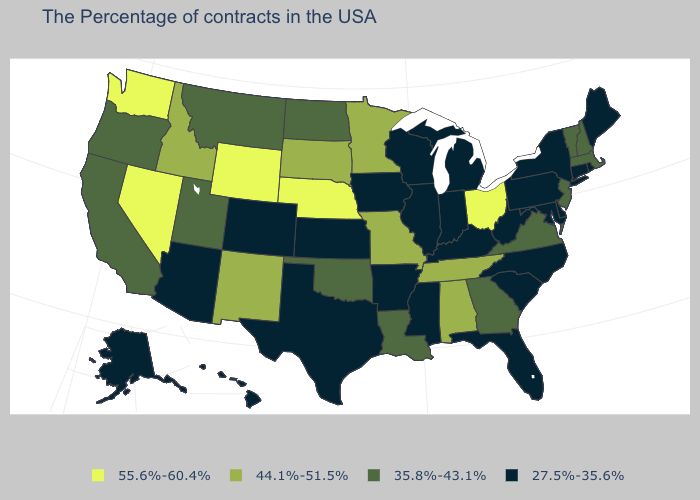Name the states that have a value in the range 35.8%-43.1%?
Short answer required. Massachusetts, New Hampshire, Vermont, New Jersey, Virginia, Georgia, Louisiana, Oklahoma, North Dakota, Utah, Montana, California, Oregon. Which states have the highest value in the USA?
Keep it brief. Ohio, Nebraska, Wyoming, Nevada, Washington. Does Alaska have the lowest value in the West?
Short answer required. Yes. What is the value of Louisiana?
Answer briefly. 35.8%-43.1%. What is the value of Minnesota?
Keep it brief. 44.1%-51.5%. Name the states that have a value in the range 55.6%-60.4%?
Short answer required. Ohio, Nebraska, Wyoming, Nevada, Washington. Does Wisconsin have the lowest value in the USA?
Quick response, please. Yes. Does Utah have the lowest value in the USA?
Quick response, please. No. Name the states that have a value in the range 44.1%-51.5%?
Concise answer only. Alabama, Tennessee, Missouri, Minnesota, South Dakota, New Mexico, Idaho. What is the value of Illinois?
Concise answer only. 27.5%-35.6%. Does Tennessee have the highest value in the South?
Concise answer only. Yes. What is the value of South Dakota?
Short answer required. 44.1%-51.5%. Does Ohio have the highest value in the USA?
Short answer required. Yes. Does Oregon have the same value as Florida?
Answer briefly. No. Name the states that have a value in the range 44.1%-51.5%?
Give a very brief answer. Alabama, Tennessee, Missouri, Minnesota, South Dakota, New Mexico, Idaho. 